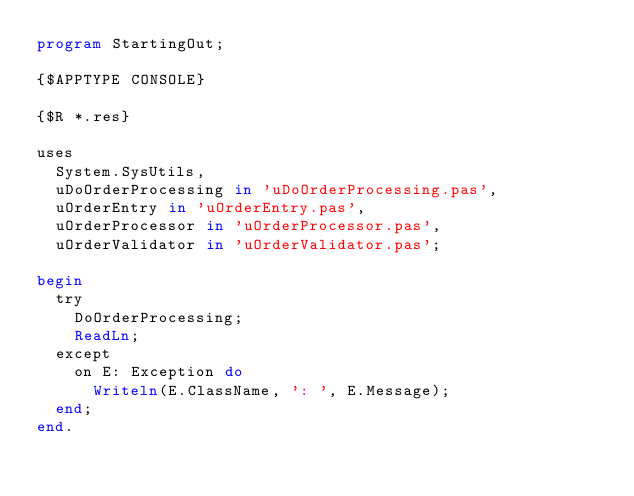Convert code to text. <code><loc_0><loc_0><loc_500><loc_500><_Pascal_>program StartingOut;

{$APPTYPE CONSOLE}

{$R *.res}

uses
  System.SysUtils,
  uDoOrderProcessing in 'uDoOrderProcessing.pas',
  uOrderEntry in 'uOrderEntry.pas',
  uOrderProcessor in 'uOrderProcessor.pas',
  uOrderValidator in 'uOrderValidator.pas';

begin
  try
    DoOrderProcessing;
    ReadLn;
  except
    on E: Exception do
      Writeln(E.ClassName, ': ', E.Message);
  end;
end.
</code> 